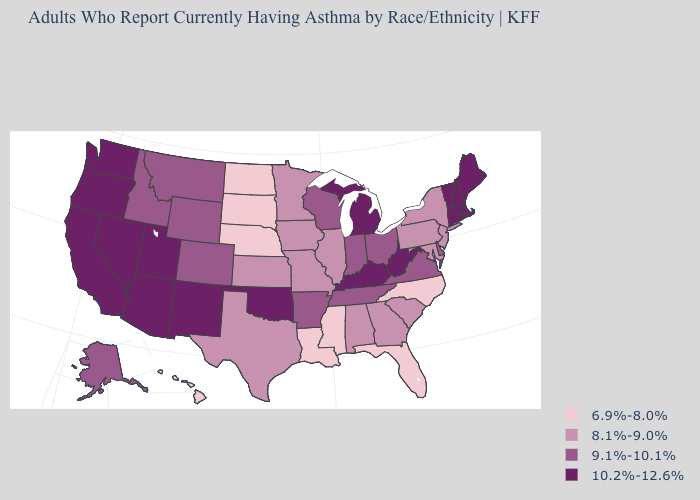Does Mississippi have the lowest value in the USA?
Short answer required. Yes. Name the states that have a value in the range 9.1%-10.1%?
Concise answer only. Alaska, Arkansas, Colorado, Delaware, Idaho, Indiana, Montana, Ohio, Tennessee, Virginia, Wisconsin, Wyoming. Among the states that border West Virginia , which have the highest value?
Answer briefly. Kentucky. Does the first symbol in the legend represent the smallest category?
Give a very brief answer. Yes. Does California have the lowest value in the West?
Give a very brief answer. No. What is the value of Oklahoma?
Concise answer only. 10.2%-12.6%. What is the value of Louisiana?
Answer briefly. 6.9%-8.0%. How many symbols are there in the legend?
Write a very short answer. 4. How many symbols are there in the legend?
Be succinct. 4. Among the states that border Idaho , which have the lowest value?
Give a very brief answer. Montana, Wyoming. What is the value of Louisiana?
Answer briefly. 6.9%-8.0%. What is the value of Arizona?
Short answer required. 10.2%-12.6%. Among the states that border Arizona , does Colorado have the highest value?
Write a very short answer. No. What is the value of Kansas?
Be succinct. 8.1%-9.0%. 